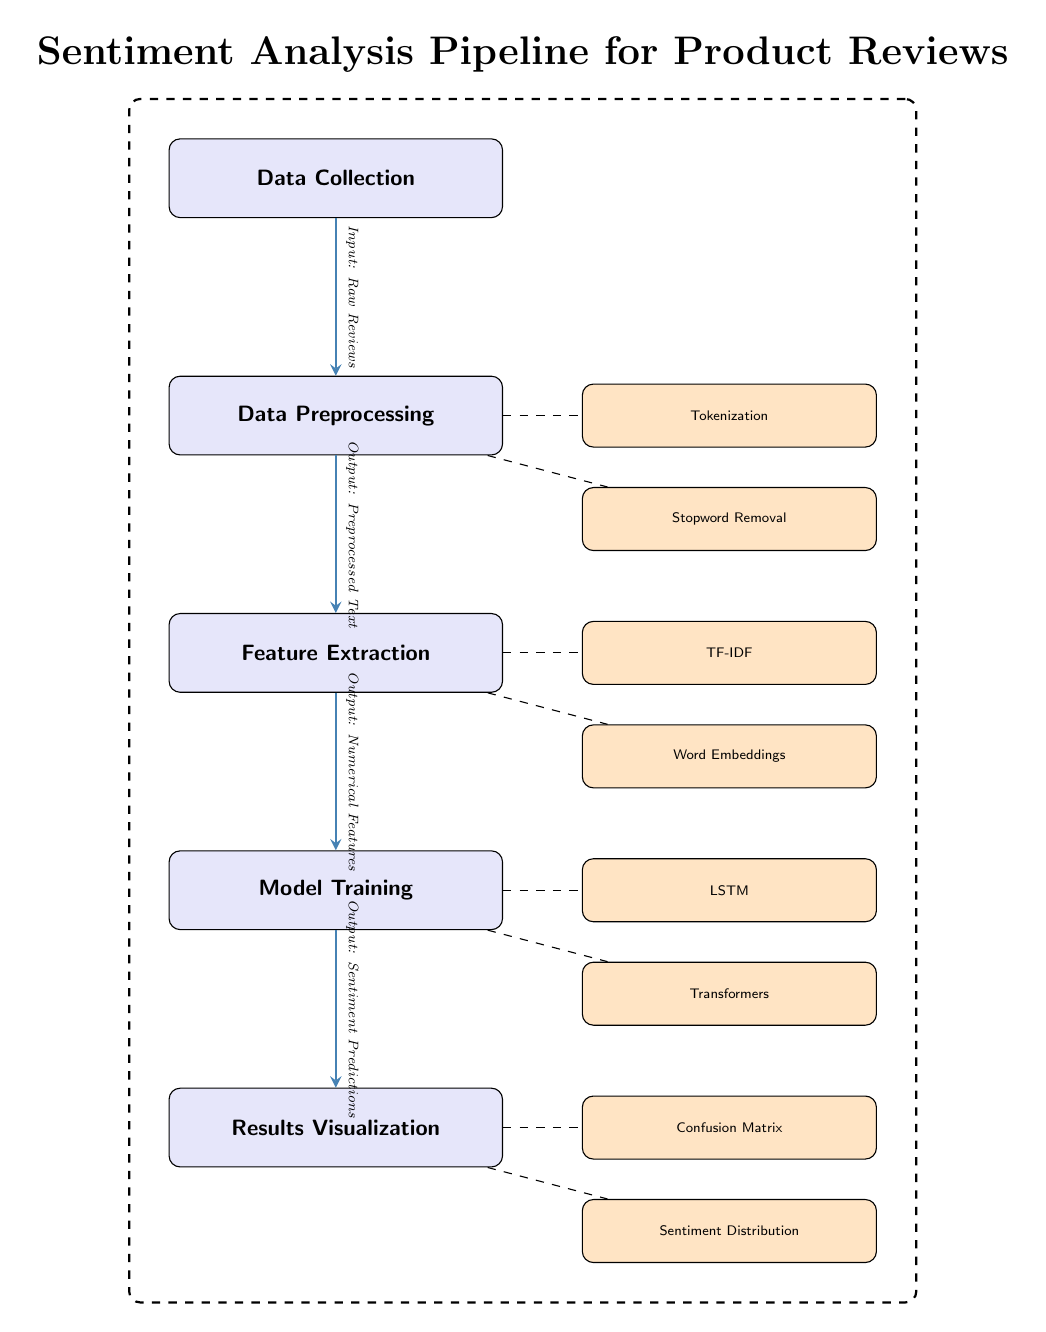What is the first stage in the pipeline? The diagram lists "Data Collection" at the top, indicating it is the starting point of the sentiment analysis process.
Answer: Data Collection How many subnodes are in the Data Preprocessing stage? The Data Preprocessing stage has two subnodes: "Tokenization" and "Stopword Removal," which are listed to the right of this stage.
Answer: 2 What is the output of Model Training? The arrow leading from Model Training shows that the output is "Sentiment Predictions," which describes the result of this stage in the pipeline.
Answer: Sentiment Predictions Which methods are utilized in Feature Extraction? Feature Extraction has two subnodes listed: "TF-IDF" and "Word Embeddings," which provide the techniques used for extracting features from the preprocessed text.
Answer: TF-IDF, Word Embeddings How does the data flow from Feature Extraction to Model Training? An edge connects Feature Extraction to Model Training, indicating that the "Numerical Features" produced in Feature Extraction are the input for Model Training.
Answer: Numerical Features What is used for results visualization? The diagram indicates that "Confusion Matrix" and "Sentiment Distribution" are the two components used for visualizing the results after model predictions.
Answer: Confusion Matrix, Sentiment Distribution What processes are included in the Model Training stage? The Model Training stage lists two subnodes: "LSTM" and "Transformers," which represent the specific algorithms applied during this phase.
Answer: LSTM, Transformers How many main nodes are present in the diagram? Counting the main nodes in the diagram reveals five distinct stages: Data Collection, Data Preprocessing, Feature Extraction, Model Training, and Results Visualization.
Answer: 5 What type of diagram is this? The diagram illustrates a process for performing sentiment analysis using various stages and methods specifically, showing the end-to-end workflow in Natural Language Processing.
Answer: Machine Learning Diagram 